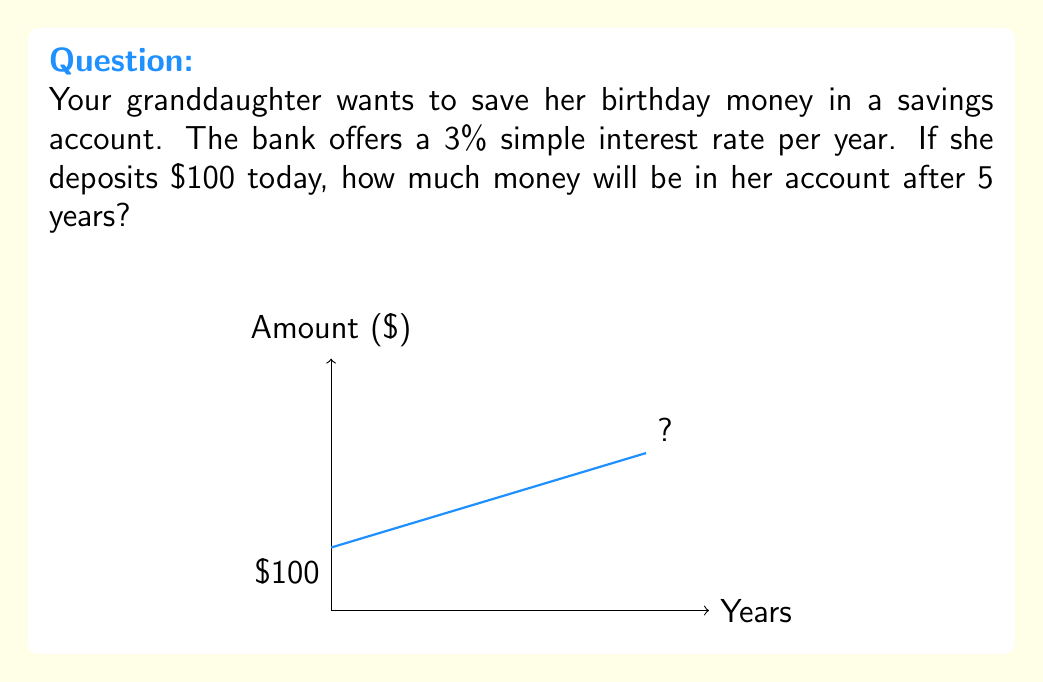Teach me how to tackle this problem. Let's break this down step-by-step:

1) The formula for simple interest is:
   $$ A = P(1 + rt) $$
   Where:
   $A$ = Final amount
   $P$ = Principal (initial deposit)
   $r$ = Annual interest rate (as a decimal)
   $t$ = Time in years

2) We know:
   $P = \$100$ (initial deposit)
   $r = 0.03$ (3% written as a decimal)
   $t = 5$ years

3) Let's plug these values into our formula:
   $$ A = 100(1 + 0.03 \times 5) $$

4) First, calculate inside the parentheses:
   $$ A = 100(1 + 0.15) = 100(1.15) $$

5) Now multiply:
   $$ A = 115 $$

Therefore, after 5 years, there will be $115 in the account.
Answer: $115 